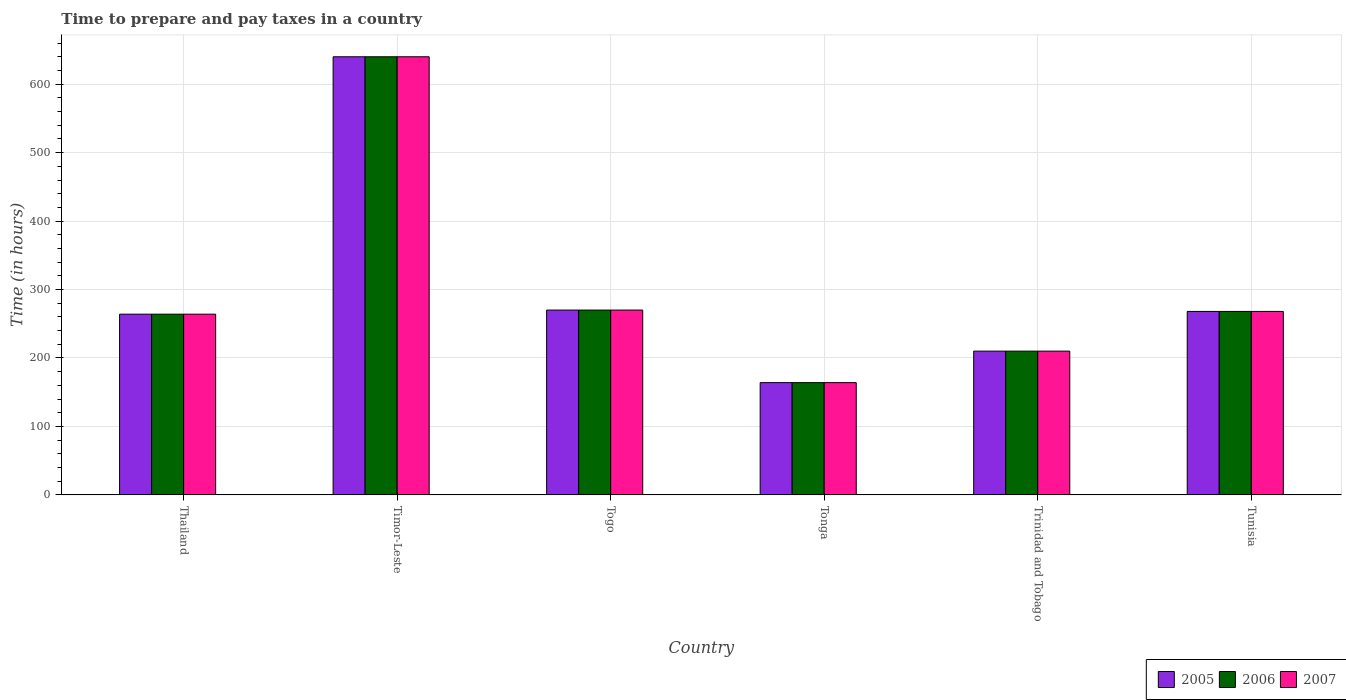What is the label of the 5th group of bars from the left?
Provide a succinct answer. Trinidad and Tobago. What is the number of hours required to prepare and pay taxes in 2007 in Trinidad and Tobago?
Ensure brevity in your answer.  210. Across all countries, what is the maximum number of hours required to prepare and pay taxes in 2005?
Provide a short and direct response. 640. Across all countries, what is the minimum number of hours required to prepare and pay taxes in 2005?
Offer a terse response. 164. In which country was the number of hours required to prepare and pay taxes in 2005 maximum?
Your answer should be compact. Timor-Leste. In which country was the number of hours required to prepare and pay taxes in 2006 minimum?
Your answer should be very brief. Tonga. What is the total number of hours required to prepare and pay taxes in 2006 in the graph?
Provide a short and direct response. 1816. What is the difference between the number of hours required to prepare and pay taxes in 2005 in Thailand and that in Togo?
Your answer should be very brief. -6. What is the average number of hours required to prepare and pay taxes in 2006 per country?
Ensure brevity in your answer.  302.67. What is the ratio of the number of hours required to prepare and pay taxes in 2006 in Thailand to that in Timor-Leste?
Keep it short and to the point. 0.41. What is the difference between the highest and the second highest number of hours required to prepare and pay taxes in 2006?
Provide a succinct answer. 372. What is the difference between the highest and the lowest number of hours required to prepare and pay taxes in 2007?
Your response must be concise. 476. Is the sum of the number of hours required to prepare and pay taxes in 2006 in Trinidad and Tobago and Tunisia greater than the maximum number of hours required to prepare and pay taxes in 2007 across all countries?
Provide a succinct answer. No. What does the 3rd bar from the left in Thailand represents?
Ensure brevity in your answer.  2007. What does the 1st bar from the right in Trinidad and Tobago represents?
Make the answer very short. 2007. Is it the case that in every country, the sum of the number of hours required to prepare and pay taxes in 2005 and number of hours required to prepare and pay taxes in 2006 is greater than the number of hours required to prepare and pay taxes in 2007?
Provide a succinct answer. Yes. How many bars are there?
Ensure brevity in your answer.  18. Are all the bars in the graph horizontal?
Offer a very short reply. No. How many countries are there in the graph?
Make the answer very short. 6. What is the difference between two consecutive major ticks on the Y-axis?
Your response must be concise. 100. Are the values on the major ticks of Y-axis written in scientific E-notation?
Provide a short and direct response. No. Does the graph contain any zero values?
Offer a very short reply. No. Where does the legend appear in the graph?
Give a very brief answer. Bottom right. How many legend labels are there?
Your response must be concise. 3. How are the legend labels stacked?
Your answer should be very brief. Horizontal. What is the title of the graph?
Make the answer very short. Time to prepare and pay taxes in a country. What is the label or title of the Y-axis?
Offer a very short reply. Time (in hours). What is the Time (in hours) in 2005 in Thailand?
Keep it short and to the point. 264. What is the Time (in hours) in 2006 in Thailand?
Keep it short and to the point. 264. What is the Time (in hours) of 2007 in Thailand?
Your answer should be compact. 264. What is the Time (in hours) of 2005 in Timor-Leste?
Give a very brief answer. 640. What is the Time (in hours) of 2006 in Timor-Leste?
Your answer should be very brief. 640. What is the Time (in hours) in 2007 in Timor-Leste?
Your answer should be very brief. 640. What is the Time (in hours) in 2005 in Togo?
Provide a succinct answer. 270. What is the Time (in hours) in 2006 in Togo?
Make the answer very short. 270. What is the Time (in hours) in 2007 in Togo?
Provide a short and direct response. 270. What is the Time (in hours) of 2005 in Tonga?
Offer a terse response. 164. What is the Time (in hours) of 2006 in Tonga?
Offer a very short reply. 164. What is the Time (in hours) in 2007 in Tonga?
Ensure brevity in your answer.  164. What is the Time (in hours) of 2005 in Trinidad and Tobago?
Your answer should be very brief. 210. What is the Time (in hours) of 2006 in Trinidad and Tobago?
Provide a succinct answer. 210. What is the Time (in hours) of 2007 in Trinidad and Tobago?
Provide a succinct answer. 210. What is the Time (in hours) in 2005 in Tunisia?
Make the answer very short. 268. What is the Time (in hours) in 2006 in Tunisia?
Keep it short and to the point. 268. What is the Time (in hours) in 2007 in Tunisia?
Give a very brief answer. 268. Across all countries, what is the maximum Time (in hours) in 2005?
Give a very brief answer. 640. Across all countries, what is the maximum Time (in hours) in 2006?
Your response must be concise. 640. Across all countries, what is the maximum Time (in hours) in 2007?
Make the answer very short. 640. Across all countries, what is the minimum Time (in hours) of 2005?
Ensure brevity in your answer.  164. Across all countries, what is the minimum Time (in hours) of 2006?
Offer a terse response. 164. Across all countries, what is the minimum Time (in hours) of 2007?
Your response must be concise. 164. What is the total Time (in hours) in 2005 in the graph?
Provide a succinct answer. 1816. What is the total Time (in hours) in 2006 in the graph?
Provide a succinct answer. 1816. What is the total Time (in hours) of 2007 in the graph?
Give a very brief answer. 1816. What is the difference between the Time (in hours) of 2005 in Thailand and that in Timor-Leste?
Your response must be concise. -376. What is the difference between the Time (in hours) of 2006 in Thailand and that in Timor-Leste?
Keep it short and to the point. -376. What is the difference between the Time (in hours) of 2007 in Thailand and that in Timor-Leste?
Give a very brief answer. -376. What is the difference between the Time (in hours) of 2007 in Thailand and that in Togo?
Offer a terse response. -6. What is the difference between the Time (in hours) of 2005 in Thailand and that in Tonga?
Give a very brief answer. 100. What is the difference between the Time (in hours) in 2007 in Thailand and that in Trinidad and Tobago?
Ensure brevity in your answer.  54. What is the difference between the Time (in hours) of 2007 in Thailand and that in Tunisia?
Give a very brief answer. -4. What is the difference between the Time (in hours) of 2005 in Timor-Leste and that in Togo?
Your answer should be compact. 370. What is the difference between the Time (in hours) in 2006 in Timor-Leste and that in Togo?
Give a very brief answer. 370. What is the difference between the Time (in hours) of 2007 in Timor-Leste and that in Togo?
Your answer should be very brief. 370. What is the difference between the Time (in hours) of 2005 in Timor-Leste and that in Tonga?
Give a very brief answer. 476. What is the difference between the Time (in hours) of 2006 in Timor-Leste and that in Tonga?
Give a very brief answer. 476. What is the difference between the Time (in hours) of 2007 in Timor-Leste and that in Tonga?
Offer a terse response. 476. What is the difference between the Time (in hours) of 2005 in Timor-Leste and that in Trinidad and Tobago?
Offer a very short reply. 430. What is the difference between the Time (in hours) in 2006 in Timor-Leste and that in Trinidad and Tobago?
Provide a succinct answer. 430. What is the difference between the Time (in hours) in 2007 in Timor-Leste and that in Trinidad and Tobago?
Offer a terse response. 430. What is the difference between the Time (in hours) in 2005 in Timor-Leste and that in Tunisia?
Offer a very short reply. 372. What is the difference between the Time (in hours) of 2006 in Timor-Leste and that in Tunisia?
Provide a succinct answer. 372. What is the difference between the Time (in hours) in 2007 in Timor-Leste and that in Tunisia?
Give a very brief answer. 372. What is the difference between the Time (in hours) of 2005 in Togo and that in Tonga?
Give a very brief answer. 106. What is the difference between the Time (in hours) in 2006 in Togo and that in Tonga?
Ensure brevity in your answer.  106. What is the difference between the Time (in hours) of 2007 in Togo and that in Tonga?
Provide a succinct answer. 106. What is the difference between the Time (in hours) in 2007 in Togo and that in Trinidad and Tobago?
Provide a short and direct response. 60. What is the difference between the Time (in hours) in 2005 in Togo and that in Tunisia?
Provide a short and direct response. 2. What is the difference between the Time (in hours) of 2006 in Togo and that in Tunisia?
Provide a succinct answer. 2. What is the difference between the Time (in hours) in 2005 in Tonga and that in Trinidad and Tobago?
Your answer should be compact. -46. What is the difference between the Time (in hours) in 2006 in Tonga and that in Trinidad and Tobago?
Give a very brief answer. -46. What is the difference between the Time (in hours) in 2007 in Tonga and that in Trinidad and Tobago?
Your response must be concise. -46. What is the difference between the Time (in hours) of 2005 in Tonga and that in Tunisia?
Provide a succinct answer. -104. What is the difference between the Time (in hours) in 2006 in Tonga and that in Tunisia?
Your response must be concise. -104. What is the difference between the Time (in hours) of 2007 in Tonga and that in Tunisia?
Your response must be concise. -104. What is the difference between the Time (in hours) of 2005 in Trinidad and Tobago and that in Tunisia?
Offer a very short reply. -58. What is the difference between the Time (in hours) in 2006 in Trinidad and Tobago and that in Tunisia?
Offer a very short reply. -58. What is the difference between the Time (in hours) of 2007 in Trinidad and Tobago and that in Tunisia?
Make the answer very short. -58. What is the difference between the Time (in hours) of 2005 in Thailand and the Time (in hours) of 2006 in Timor-Leste?
Ensure brevity in your answer.  -376. What is the difference between the Time (in hours) of 2005 in Thailand and the Time (in hours) of 2007 in Timor-Leste?
Keep it short and to the point. -376. What is the difference between the Time (in hours) in 2006 in Thailand and the Time (in hours) in 2007 in Timor-Leste?
Offer a terse response. -376. What is the difference between the Time (in hours) of 2005 in Thailand and the Time (in hours) of 2007 in Togo?
Offer a terse response. -6. What is the difference between the Time (in hours) of 2006 in Thailand and the Time (in hours) of 2007 in Togo?
Offer a very short reply. -6. What is the difference between the Time (in hours) in 2006 in Thailand and the Time (in hours) in 2007 in Tonga?
Offer a terse response. 100. What is the difference between the Time (in hours) in 2005 in Thailand and the Time (in hours) in 2006 in Trinidad and Tobago?
Your response must be concise. 54. What is the difference between the Time (in hours) of 2005 in Thailand and the Time (in hours) of 2007 in Trinidad and Tobago?
Make the answer very short. 54. What is the difference between the Time (in hours) in 2005 in Thailand and the Time (in hours) in 2007 in Tunisia?
Your answer should be compact. -4. What is the difference between the Time (in hours) in 2005 in Timor-Leste and the Time (in hours) in 2006 in Togo?
Ensure brevity in your answer.  370. What is the difference between the Time (in hours) of 2005 in Timor-Leste and the Time (in hours) of 2007 in Togo?
Your answer should be very brief. 370. What is the difference between the Time (in hours) of 2006 in Timor-Leste and the Time (in hours) of 2007 in Togo?
Provide a short and direct response. 370. What is the difference between the Time (in hours) in 2005 in Timor-Leste and the Time (in hours) in 2006 in Tonga?
Provide a short and direct response. 476. What is the difference between the Time (in hours) in 2005 in Timor-Leste and the Time (in hours) in 2007 in Tonga?
Keep it short and to the point. 476. What is the difference between the Time (in hours) in 2006 in Timor-Leste and the Time (in hours) in 2007 in Tonga?
Offer a terse response. 476. What is the difference between the Time (in hours) of 2005 in Timor-Leste and the Time (in hours) of 2006 in Trinidad and Tobago?
Keep it short and to the point. 430. What is the difference between the Time (in hours) of 2005 in Timor-Leste and the Time (in hours) of 2007 in Trinidad and Tobago?
Your response must be concise. 430. What is the difference between the Time (in hours) of 2006 in Timor-Leste and the Time (in hours) of 2007 in Trinidad and Tobago?
Make the answer very short. 430. What is the difference between the Time (in hours) of 2005 in Timor-Leste and the Time (in hours) of 2006 in Tunisia?
Your answer should be compact. 372. What is the difference between the Time (in hours) of 2005 in Timor-Leste and the Time (in hours) of 2007 in Tunisia?
Provide a short and direct response. 372. What is the difference between the Time (in hours) of 2006 in Timor-Leste and the Time (in hours) of 2007 in Tunisia?
Provide a short and direct response. 372. What is the difference between the Time (in hours) in 2005 in Togo and the Time (in hours) in 2006 in Tonga?
Offer a very short reply. 106. What is the difference between the Time (in hours) in 2005 in Togo and the Time (in hours) in 2007 in Tonga?
Keep it short and to the point. 106. What is the difference between the Time (in hours) in 2006 in Togo and the Time (in hours) in 2007 in Tonga?
Your answer should be compact. 106. What is the difference between the Time (in hours) of 2006 in Togo and the Time (in hours) of 2007 in Trinidad and Tobago?
Your response must be concise. 60. What is the difference between the Time (in hours) of 2005 in Togo and the Time (in hours) of 2007 in Tunisia?
Make the answer very short. 2. What is the difference between the Time (in hours) in 2005 in Tonga and the Time (in hours) in 2006 in Trinidad and Tobago?
Provide a short and direct response. -46. What is the difference between the Time (in hours) of 2005 in Tonga and the Time (in hours) of 2007 in Trinidad and Tobago?
Keep it short and to the point. -46. What is the difference between the Time (in hours) of 2006 in Tonga and the Time (in hours) of 2007 in Trinidad and Tobago?
Keep it short and to the point. -46. What is the difference between the Time (in hours) of 2005 in Tonga and the Time (in hours) of 2006 in Tunisia?
Provide a short and direct response. -104. What is the difference between the Time (in hours) in 2005 in Tonga and the Time (in hours) in 2007 in Tunisia?
Your response must be concise. -104. What is the difference between the Time (in hours) in 2006 in Tonga and the Time (in hours) in 2007 in Tunisia?
Your answer should be very brief. -104. What is the difference between the Time (in hours) of 2005 in Trinidad and Tobago and the Time (in hours) of 2006 in Tunisia?
Offer a very short reply. -58. What is the difference between the Time (in hours) in 2005 in Trinidad and Tobago and the Time (in hours) in 2007 in Tunisia?
Offer a terse response. -58. What is the difference between the Time (in hours) in 2006 in Trinidad and Tobago and the Time (in hours) in 2007 in Tunisia?
Your answer should be compact. -58. What is the average Time (in hours) of 2005 per country?
Provide a short and direct response. 302.67. What is the average Time (in hours) of 2006 per country?
Make the answer very short. 302.67. What is the average Time (in hours) in 2007 per country?
Keep it short and to the point. 302.67. What is the difference between the Time (in hours) in 2005 and Time (in hours) in 2006 in Thailand?
Provide a succinct answer. 0. What is the difference between the Time (in hours) of 2005 and Time (in hours) of 2007 in Thailand?
Make the answer very short. 0. What is the difference between the Time (in hours) in 2005 and Time (in hours) in 2006 in Timor-Leste?
Make the answer very short. 0. What is the difference between the Time (in hours) of 2005 and Time (in hours) of 2007 in Timor-Leste?
Ensure brevity in your answer.  0. What is the difference between the Time (in hours) in 2006 and Time (in hours) in 2007 in Timor-Leste?
Keep it short and to the point. 0. What is the difference between the Time (in hours) in 2005 and Time (in hours) in 2006 in Togo?
Offer a very short reply. 0. What is the difference between the Time (in hours) in 2006 and Time (in hours) in 2007 in Tonga?
Offer a terse response. 0. What is the difference between the Time (in hours) of 2005 and Time (in hours) of 2007 in Trinidad and Tobago?
Offer a terse response. 0. What is the difference between the Time (in hours) in 2006 and Time (in hours) in 2007 in Trinidad and Tobago?
Give a very brief answer. 0. What is the difference between the Time (in hours) in 2005 and Time (in hours) in 2006 in Tunisia?
Your answer should be very brief. 0. What is the difference between the Time (in hours) of 2005 and Time (in hours) of 2007 in Tunisia?
Offer a very short reply. 0. What is the ratio of the Time (in hours) of 2005 in Thailand to that in Timor-Leste?
Provide a short and direct response. 0.41. What is the ratio of the Time (in hours) in 2006 in Thailand to that in Timor-Leste?
Your response must be concise. 0.41. What is the ratio of the Time (in hours) in 2007 in Thailand to that in Timor-Leste?
Give a very brief answer. 0.41. What is the ratio of the Time (in hours) of 2005 in Thailand to that in Togo?
Provide a succinct answer. 0.98. What is the ratio of the Time (in hours) in 2006 in Thailand to that in Togo?
Your response must be concise. 0.98. What is the ratio of the Time (in hours) of 2007 in Thailand to that in Togo?
Your answer should be compact. 0.98. What is the ratio of the Time (in hours) of 2005 in Thailand to that in Tonga?
Ensure brevity in your answer.  1.61. What is the ratio of the Time (in hours) in 2006 in Thailand to that in Tonga?
Ensure brevity in your answer.  1.61. What is the ratio of the Time (in hours) in 2007 in Thailand to that in Tonga?
Ensure brevity in your answer.  1.61. What is the ratio of the Time (in hours) of 2005 in Thailand to that in Trinidad and Tobago?
Make the answer very short. 1.26. What is the ratio of the Time (in hours) in 2006 in Thailand to that in Trinidad and Tobago?
Make the answer very short. 1.26. What is the ratio of the Time (in hours) of 2007 in Thailand to that in Trinidad and Tobago?
Your response must be concise. 1.26. What is the ratio of the Time (in hours) of 2005 in Thailand to that in Tunisia?
Ensure brevity in your answer.  0.99. What is the ratio of the Time (in hours) in 2006 in Thailand to that in Tunisia?
Keep it short and to the point. 0.99. What is the ratio of the Time (in hours) of 2007 in Thailand to that in Tunisia?
Make the answer very short. 0.99. What is the ratio of the Time (in hours) of 2005 in Timor-Leste to that in Togo?
Your answer should be very brief. 2.37. What is the ratio of the Time (in hours) of 2006 in Timor-Leste to that in Togo?
Provide a short and direct response. 2.37. What is the ratio of the Time (in hours) in 2007 in Timor-Leste to that in Togo?
Your answer should be very brief. 2.37. What is the ratio of the Time (in hours) of 2005 in Timor-Leste to that in Tonga?
Keep it short and to the point. 3.9. What is the ratio of the Time (in hours) of 2006 in Timor-Leste to that in Tonga?
Offer a very short reply. 3.9. What is the ratio of the Time (in hours) of 2007 in Timor-Leste to that in Tonga?
Offer a terse response. 3.9. What is the ratio of the Time (in hours) in 2005 in Timor-Leste to that in Trinidad and Tobago?
Your answer should be very brief. 3.05. What is the ratio of the Time (in hours) in 2006 in Timor-Leste to that in Trinidad and Tobago?
Offer a very short reply. 3.05. What is the ratio of the Time (in hours) of 2007 in Timor-Leste to that in Trinidad and Tobago?
Offer a terse response. 3.05. What is the ratio of the Time (in hours) of 2005 in Timor-Leste to that in Tunisia?
Your answer should be very brief. 2.39. What is the ratio of the Time (in hours) of 2006 in Timor-Leste to that in Tunisia?
Provide a succinct answer. 2.39. What is the ratio of the Time (in hours) in 2007 in Timor-Leste to that in Tunisia?
Keep it short and to the point. 2.39. What is the ratio of the Time (in hours) in 2005 in Togo to that in Tonga?
Your response must be concise. 1.65. What is the ratio of the Time (in hours) of 2006 in Togo to that in Tonga?
Offer a terse response. 1.65. What is the ratio of the Time (in hours) in 2007 in Togo to that in Tonga?
Your answer should be compact. 1.65. What is the ratio of the Time (in hours) of 2007 in Togo to that in Trinidad and Tobago?
Make the answer very short. 1.29. What is the ratio of the Time (in hours) in 2005 in Togo to that in Tunisia?
Your answer should be very brief. 1.01. What is the ratio of the Time (in hours) in 2006 in Togo to that in Tunisia?
Make the answer very short. 1.01. What is the ratio of the Time (in hours) of 2007 in Togo to that in Tunisia?
Give a very brief answer. 1.01. What is the ratio of the Time (in hours) in 2005 in Tonga to that in Trinidad and Tobago?
Ensure brevity in your answer.  0.78. What is the ratio of the Time (in hours) of 2006 in Tonga to that in Trinidad and Tobago?
Give a very brief answer. 0.78. What is the ratio of the Time (in hours) in 2007 in Tonga to that in Trinidad and Tobago?
Your response must be concise. 0.78. What is the ratio of the Time (in hours) in 2005 in Tonga to that in Tunisia?
Ensure brevity in your answer.  0.61. What is the ratio of the Time (in hours) of 2006 in Tonga to that in Tunisia?
Provide a short and direct response. 0.61. What is the ratio of the Time (in hours) in 2007 in Tonga to that in Tunisia?
Give a very brief answer. 0.61. What is the ratio of the Time (in hours) in 2005 in Trinidad and Tobago to that in Tunisia?
Offer a very short reply. 0.78. What is the ratio of the Time (in hours) in 2006 in Trinidad and Tobago to that in Tunisia?
Ensure brevity in your answer.  0.78. What is the ratio of the Time (in hours) in 2007 in Trinidad and Tobago to that in Tunisia?
Ensure brevity in your answer.  0.78. What is the difference between the highest and the second highest Time (in hours) in 2005?
Keep it short and to the point. 370. What is the difference between the highest and the second highest Time (in hours) in 2006?
Your answer should be compact. 370. What is the difference between the highest and the second highest Time (in hours) in 2007?
Give a very brief answer. 370. What is the difference between the highest and the lowest Time (in hours) in 2005?
Offer a terse response. 476. What is the difference between the highest and the lowest Time (in hours) in 2006?
Give a very brief answer. 476. What is the difference between the highest and the lowest Time (in hours) of 2007?
Your answer should be very brief. 476. 